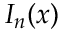<formula> <loc_0><loc_0><loc_500><loc_500>I _ { n } ( x )</formula> 